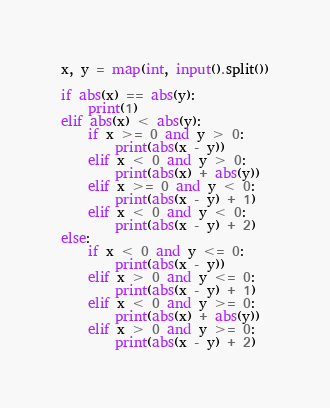Convert code to text. <code><loc_0><loc_0><loc_500><loc_500><_Python_>x, y = map(int, input().split())

if abs(x) == abs(y):
    print(1)
elif abs(x) < abs(y):
    if x >= 0 and y > 0:
        print(abs(x - y))
    elif x < 0 and y > 0:
        print(abs(x) + abs(y))
    elif x >= 0 and y < 0:
        print(abs(x - y) + 1)
    elif x < 0 and y < 0:
        print(abs(x - y) + 2)
else:
    if x < 0 and y <= 0:
        print(abs(x - y))
    elif x > 0 and y <= 0:
        print(abs(x - y) + 1)
    elif x < 0 and y >= 0:
        print(abs(x) + abs(y))
    elif x > 0 and y >= 0:
        print(abs(x - y) + 2)</code> 